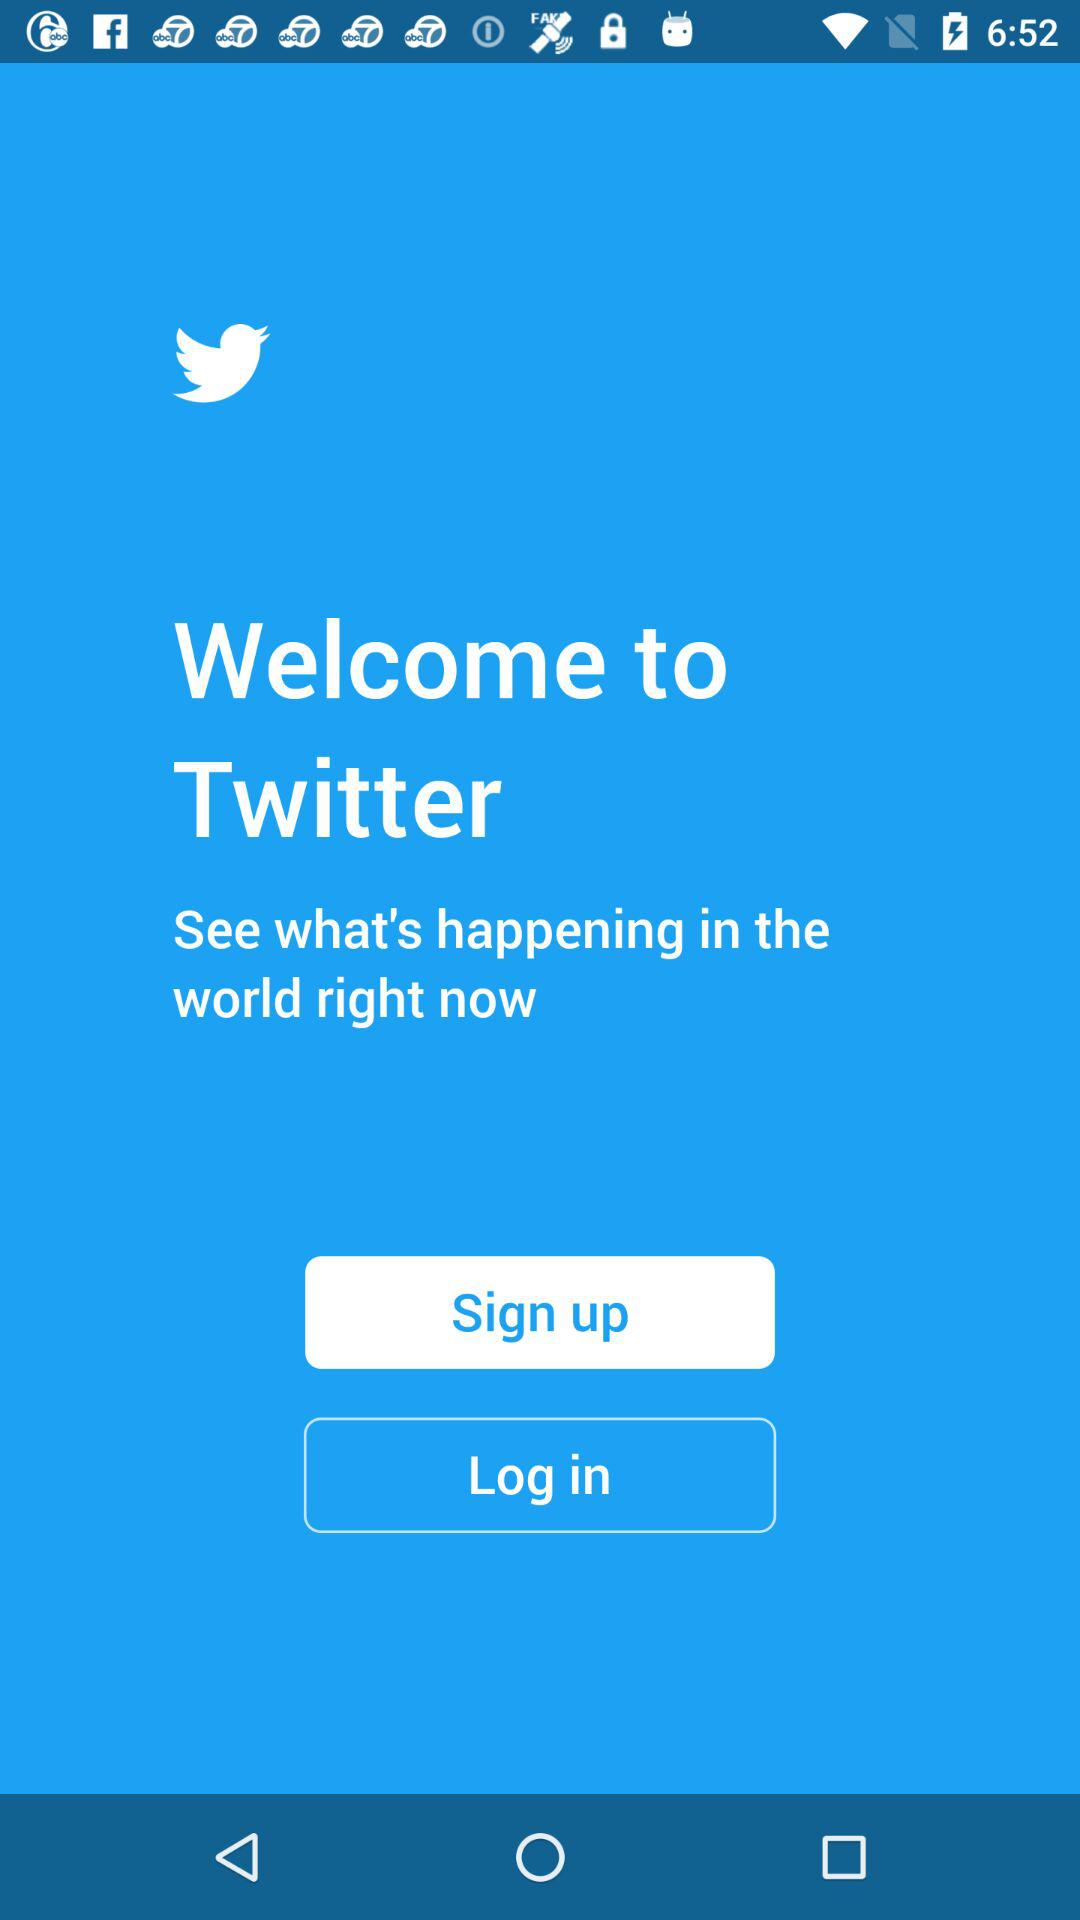What is the name of the user?
When the provided information is insufficient, respond with <no answer>. <no answer> 